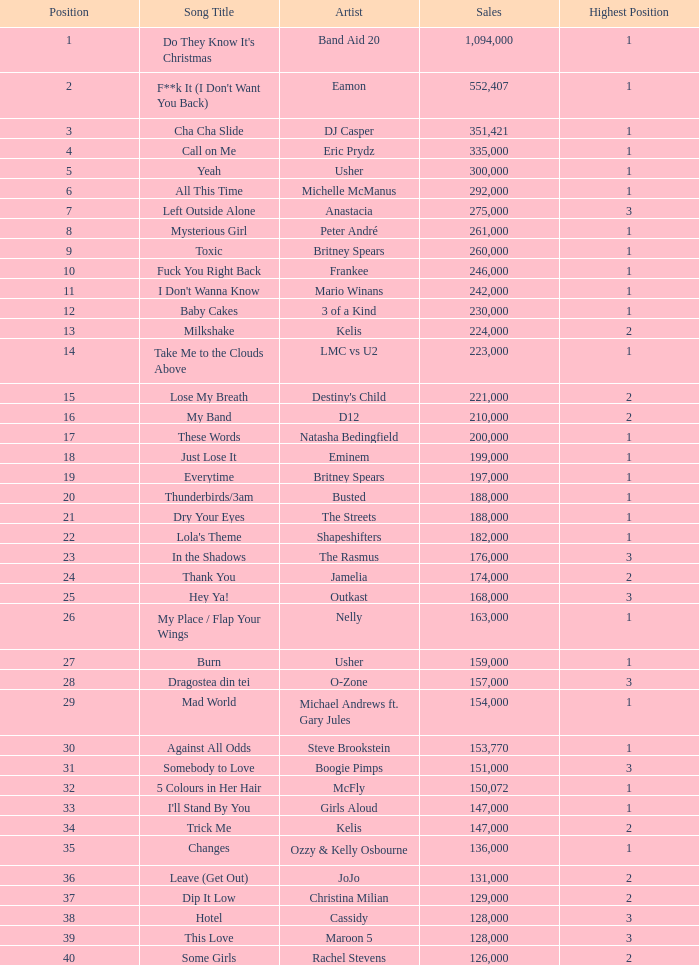What is the most sales by a song with a position higher than 3? None. 